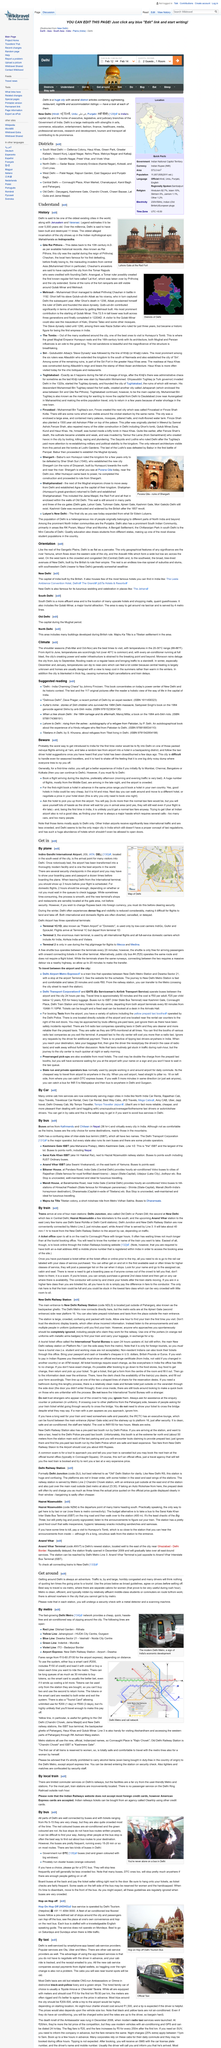Give some essential details in this illustration. The most effective method of transportation in Delhi is by utilizing the city's metro system. From April to June, the weather is typically very hot, with temperatures frequently exceeding 40 degrees. Monsoon season occurs annually from July to September, during which time rainfall is common in many parts of the world. The Delhi Transport Corporation is the major operator of buses in Delhi. The frequency of buses in Delhi is quite frequent, with buses running on most routes every 15-20 minutes, providing a reliable and convenient transportation option for the commuters. 